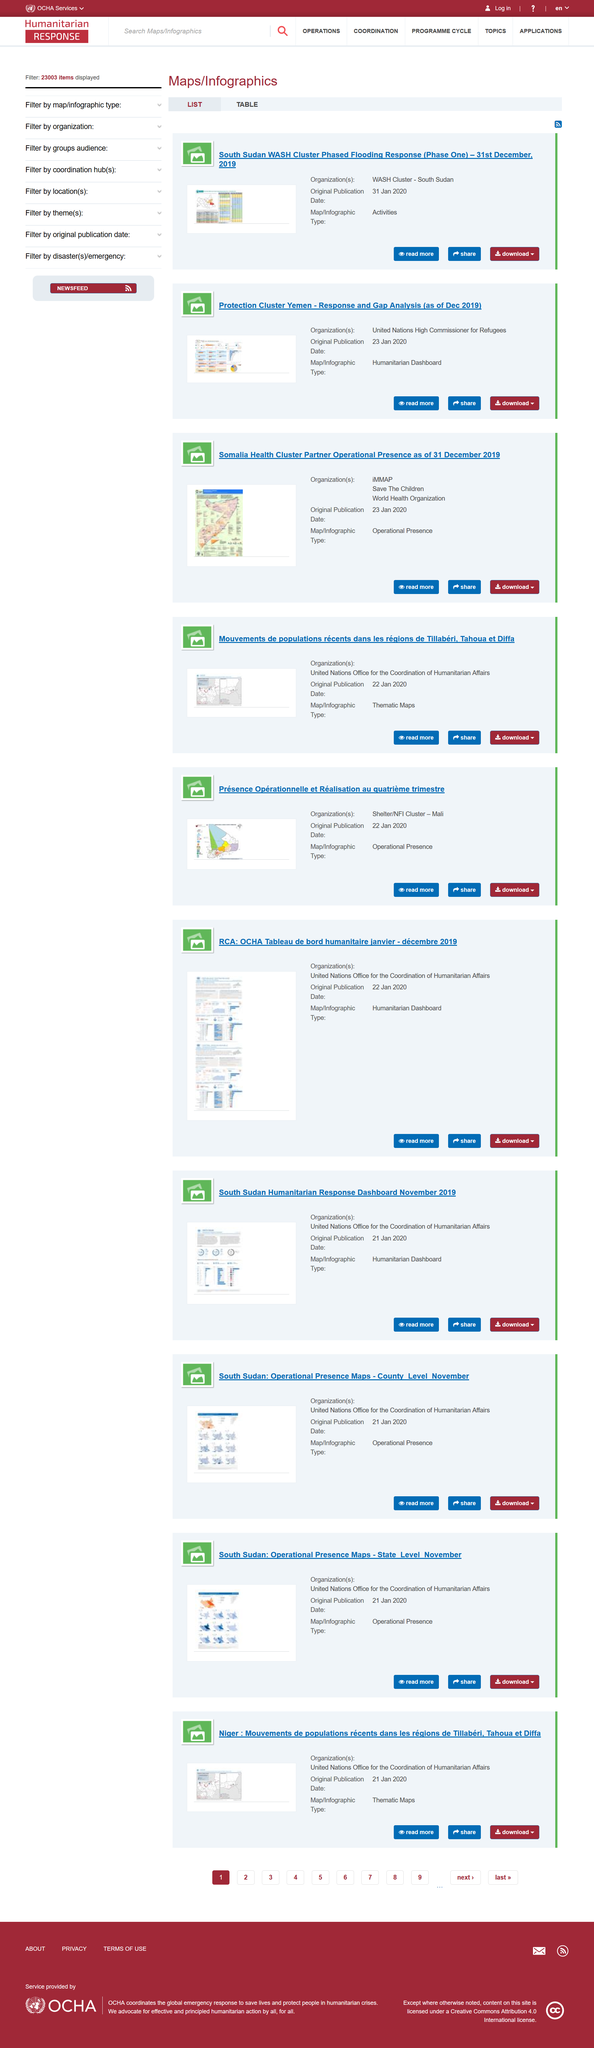Mention a couple of crucial points in this snapshot. Operational presence is a type of map or infographic. Yes, Humanitarian Dashboard is a type of map or infographic. The Protection Cluster Yemen was originally published on January 23, 2020. 